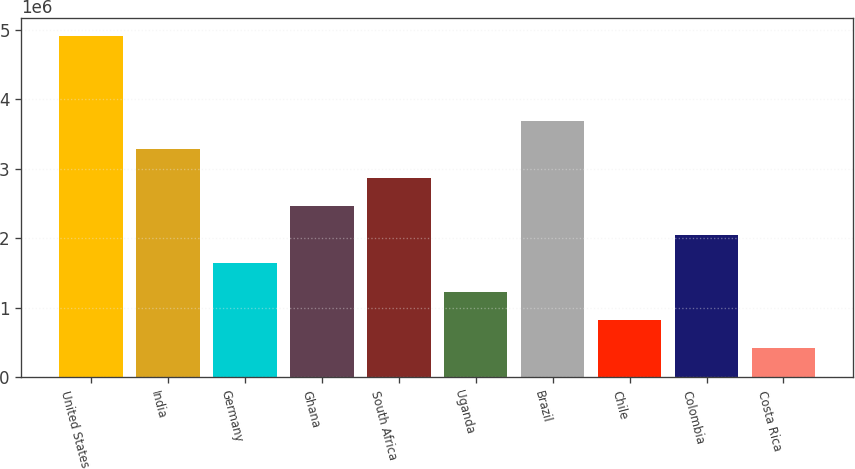<chart> <loc_0><loc_0><loc_500><loc_500><bar_chart><fcel>United States<fcel>India<fcel>Germany<fcel>Ghana<fcel>South Africa<fcel>Uganda<fcel>Brazil<fcel>Chile<fcel>Colombia<fcel>Costa Rica<nl><fcel>4.91844e+06<fcel>3.28165e+06<fcel>1.64487e+06<fcel>2.46326e+06<fcel>2.87246e+06<fcel>1.23567e+06<fcel>3.69085e+06<fcel>826472<fcel>2.05406e+06<fcel>417275<nl></chart> 